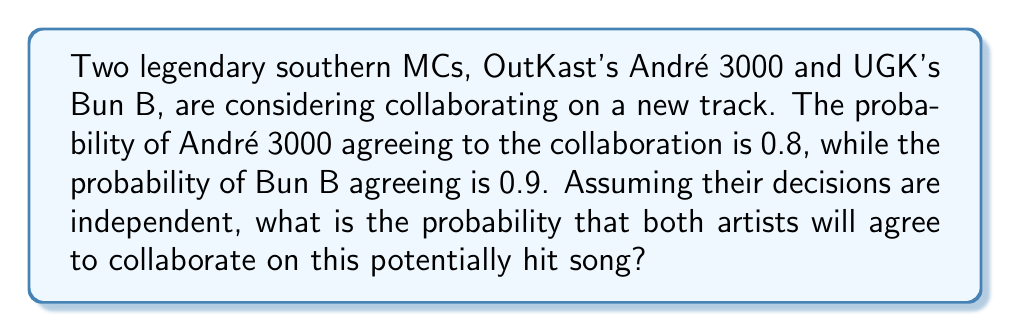Teach me how to tackle this problem. To solve this problem, we need to use the concept of independent events in probability theory.

Step 1: Identify the events
Let A be the event "André 3000 agrees to collaborate"
Let B be the event "Bun B agrees to collaborate"

Step 2: Given probabilities
P(A) = 0.8
P(B) = 0.9

Step 3: Use the multiplication rule for independent events
For independent events, the probability of both events occurring is the product of their individual probabilities.

$$P(A \text{ and } B) = P(A) \times P(B)$$

Step 4: Calculate the probability
$$P(A \text{ and } B) = 0.8 \times 0.9 = 0.72$$

Therefore, the probability that both André 3000 and Bun B will agree to collaborate on the potentially hit song is 0.72 or 72%.
Answer: 0.72 